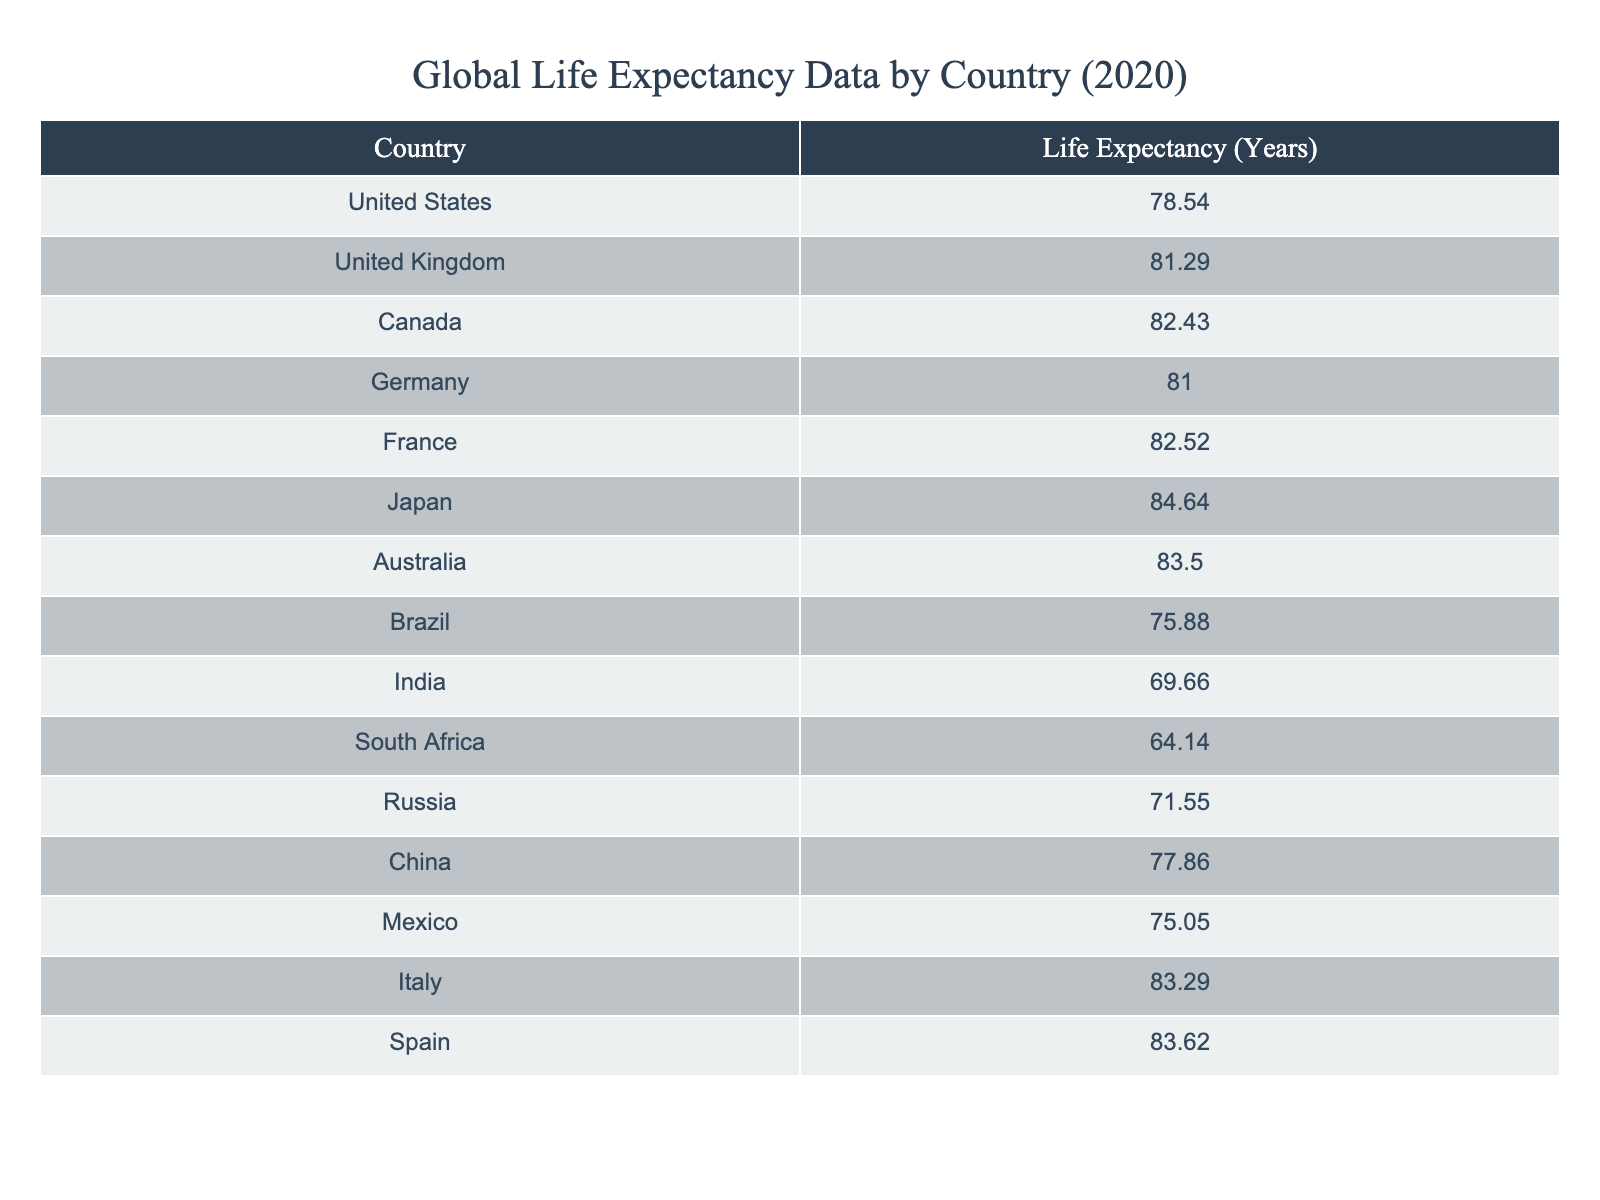What is the life expectancy of Japan? The life expectancy of Japan is explicitly stated in the table. Referring to the row for Japan, the value given is 84.64 years.
Answer: 84.64 Which country has the lowest life expectancy? The lowest life expectancy can be found by scanning through the life expectancy values listed for each country. South Africa has the lowest value at 64.14 years.
Answer: South Africa What is the average life expectancy of the countries listed? To find the average, sum all the life expectancy values (78.54 + 81.29 + 82.43 + 81.00 + 82.52 + 84.64 + 83.50 + 75.88 + 69.66 + 64.14 + 71.55 + 77.86 + 75.05 + 83.29 + 83.62 = 1,266.20) and divide by the number of countries (15). This gives us an average of approximately 84.41 years.
Answer: 84.41 Is the life expectancy of Germany greater than that of Canada? By comparing the life expectancy values in the table, Germany has a life expectancy of 81.00 years, while Canada has 82.43 years. Therefore, Germany's life expectancy is not greater than Canada's.
Answer: No What is the difference in life expectancy between the highest and lowest values in the table? The highest life expectancy is for Japan at 84.64 years, and the lowest is for South Africa at 64.14 years. Subtracting the lowest from the highest (84.64 - 64.14) results in a difference of 20.50 years.
Answer: 20.50 Which country has a longer life expectancy, Italy or France? Looking at the life expectancy values for Italy (83.29 years) and France (82.52 years) in the table, Italy has a longer life expectancy than France.
Answer: Italy How many countries have a life expectancy above 80 years? To find the number of countries above 80 years, we can review the life expectancy values and count: UK (81.29), Canada (82.43), France (82.52), Japan (84.64), Australia (83.50), Italy (83.29), and Spain (83.62). This totals to 7 countries.
Answer: 7 Is the average life expectancy of the countries in the table above 75 years? To determine if the average is above 75 years, we already calculated the average to be approximately 84.41 years, which is indeed above 75.
Answer: Yes 